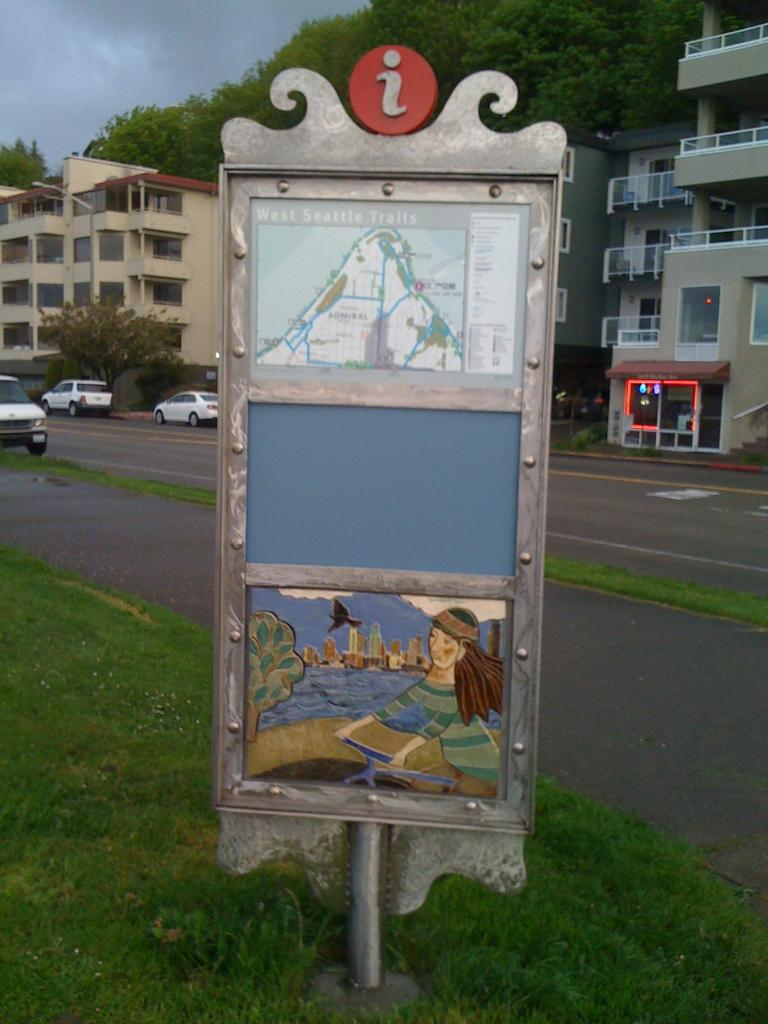What is located at the front of the image? There is a board in the front of the image. What type of vegetation is on the left side of the image? There is grass on the left side of the image. What can be seen on the road in the image? There are cars on the road in the image. What structures are visible in the background of the image? There are buildings in the background of the image. What type of natural elements are visible in the background of the image? There are trees in the background of the image. What is visible at the top of the image? The sky is visible at the top of the image. How does the family interact with the self in the image? There is no family or self present in the image; it features a board, grass, cars, buildings, trees, and the sky. 